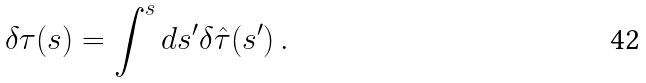Convert formula to latex. <formula><loc_0><loc_0><loc_500><loc_500>\delta \tau ( s ) = \int ^ { s } d s ^ { \prime } \delta \hat { \tau } ( s ^ { \prime } ) \, .</formula> 